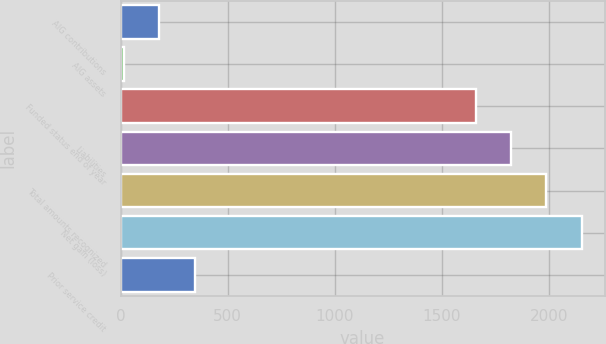Convert chart. <chart><loc_0><loc_0><loc_500><loc_500><bar_chart><fcel>AIG contributions<fcel>AIG assets<fcel>Funded status end of year<fcel>Liabilities<fcel>Total amounts recognized<fcel>Net gain (loss)<fcel>Prior service credit<nl><fcel>180.2<fcel>15<fcel>1658<fcel>1823.2<fcel>1988.4<fcel>2153.6<fcel>345.4<nl></chart> 